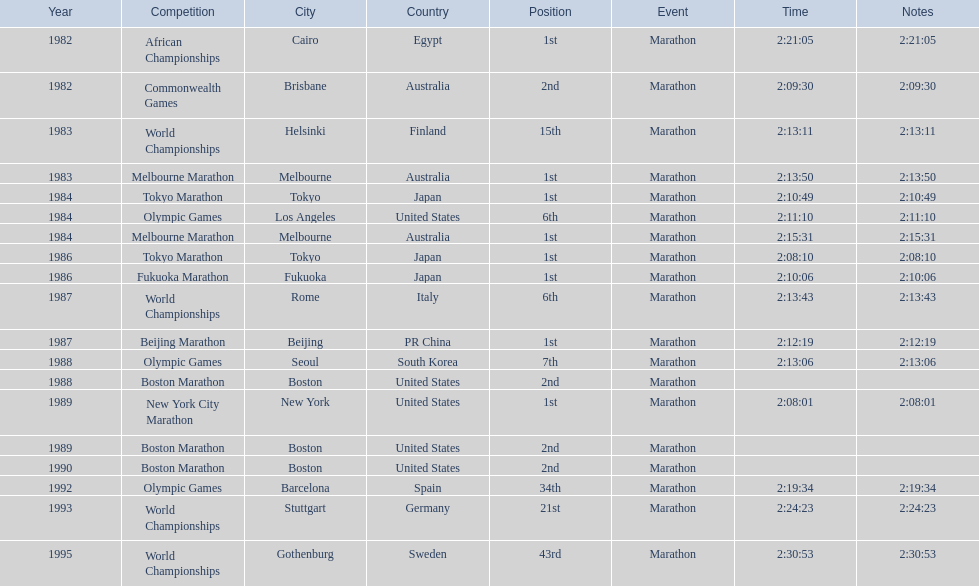What are all of the juma ikangaa competitions? African Championships, Commonwealth Games, World Championships, Melbourne Marathon, Tokyo Marathon, Olympic Games, Melbourne Marathon, Tokyo Marathon, Fukuoka Marathon, World Championships, Beijing Marathon, Olympic Games, Boston Marathon, New York City Marathon, Boston Marathon, Boston Marathon, Olympic Games, World Championships, World Championships. Which of these competitions did not take place in the united states? African Championships, Commonwealth Games, World Championships, Melbourne Marathon, Tokyo Marathon, Melbourne Marathon, Tokyo Marathon, Fukuoka Marathon, World Championships, Beijing Marathon, Olympic Games, Olympic Games, World Championships, World Championships. Out of these, which of them took place in asia? Tokyo Marathon, Tokyo Marathon, Fukuoka Marathon, Beijing Marathon, Olympic Games. Which of the remaining competitions took place in china? Beijing Marathon. 